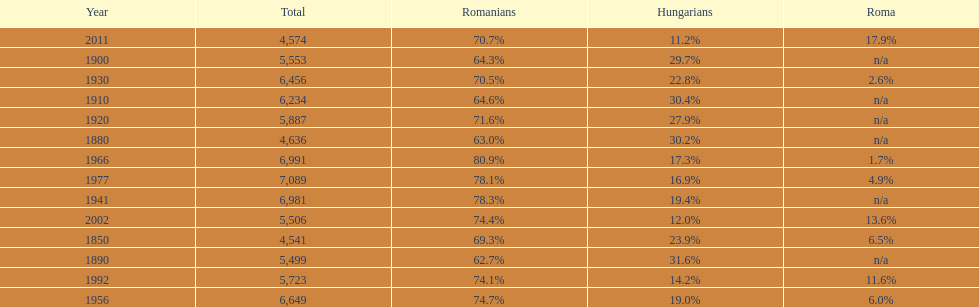What were the total number of times the romanians had a population percentage above 70%? 9. 